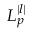Convert formula to latex. <formula><loc_0><loc_0><loc_500><loc_500>L _ { p } ^ { | l | }</formula> 